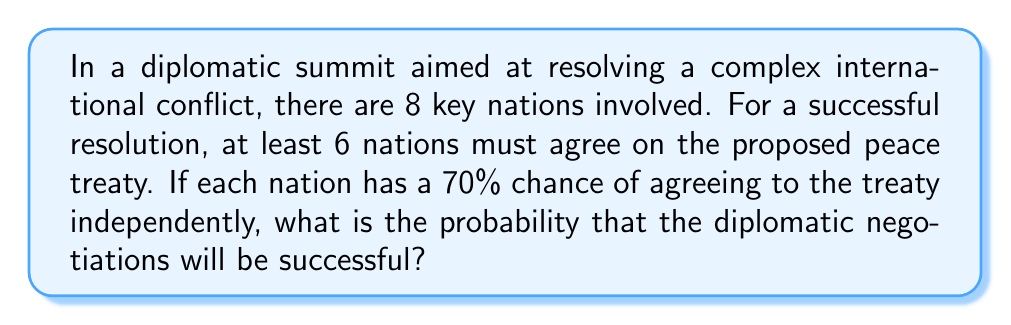Help me with this question. To solve this problem, we need to use the concept of binomial probability. Let's break it down step by step:

1) We have a binomial situation where:
   - There are $n = 8$ independent trials (nations)
   - Each trial has a probability of success $p = 0.70$ (70% chance of agreeing)
   - We need at least $k = 6$ successes for the negotiations to be successful

2) The probability of success is the sum of the probabilities of exactly 6, 7, or 8 nations agreeing. We can express this using the binomial probability formula:

   $$P(\text{success}) = P(X \geq 6) = P(X=6) + P(X=7) + P(X=8)$$

   where $X$ is the number of nations agreeing.

3) The binomial probability formula is:

   $$P(X=k) = \binom{n}{k} p^k (1-p)^{n-k}$$

4) Let's calculate each term:

   For $k = 6$:
   $$P(X=6) = \binom{8}{6} (0.70)^6 (0.30)^2 = 28 \times 0.117649 \times 0.09 = 0.2966$$

   For $k = 7$:
   $$P(X=7) = \binom{8}{7} (0.70)^7 (0.30)^1 = 8 \times 0.082354 \times 0.30 = 0.1976$$

   For $k = 8$:
   $$P(X=8) = \binom{8}{8} (0.70)^8 (0.30)^0 = 1 \times 0.057648 \times 1 = 0.0576$$

5) Sum these probabilities:

   $$P(\text{success}) = 0.2966 + 0.1976 + 0.0576 = 0.5518$$

Therefore, the probability of successful diplomatic negotiations is approximately 0.5518 or 55.18%.
Answer: 0.5518 or 55.18% 